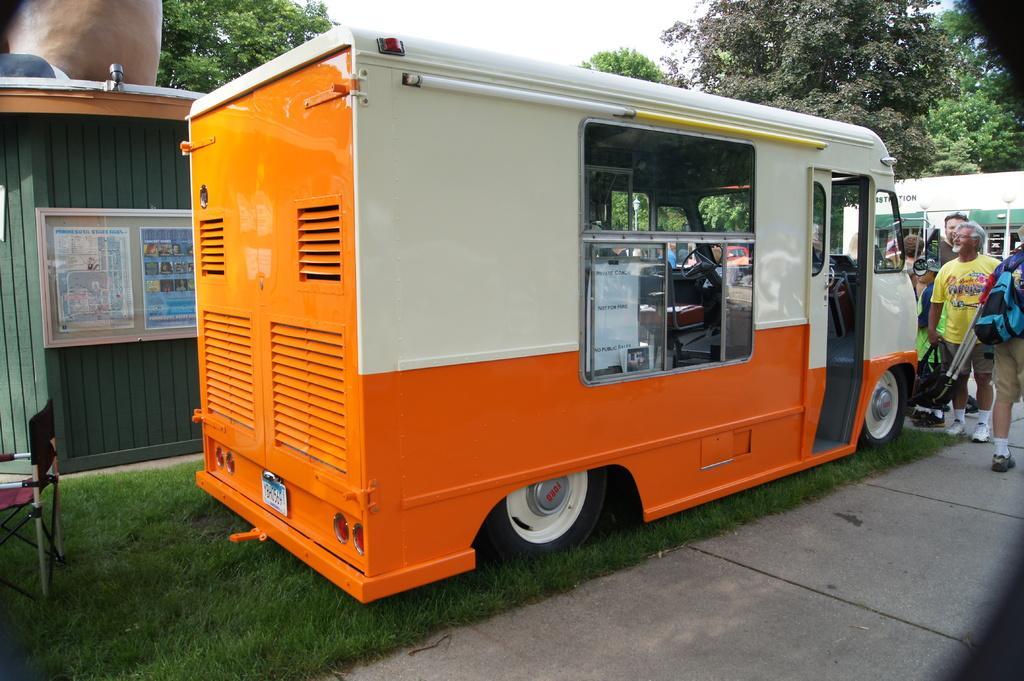Describe this image in one or two sentences. In this picture we can see a vehicle on the grass. On the right side of the image, there is a group of people. On the left side of the image, there is a chair and there is a board which is attached to an object. Behind the vehicle, there are trees and the sky. 